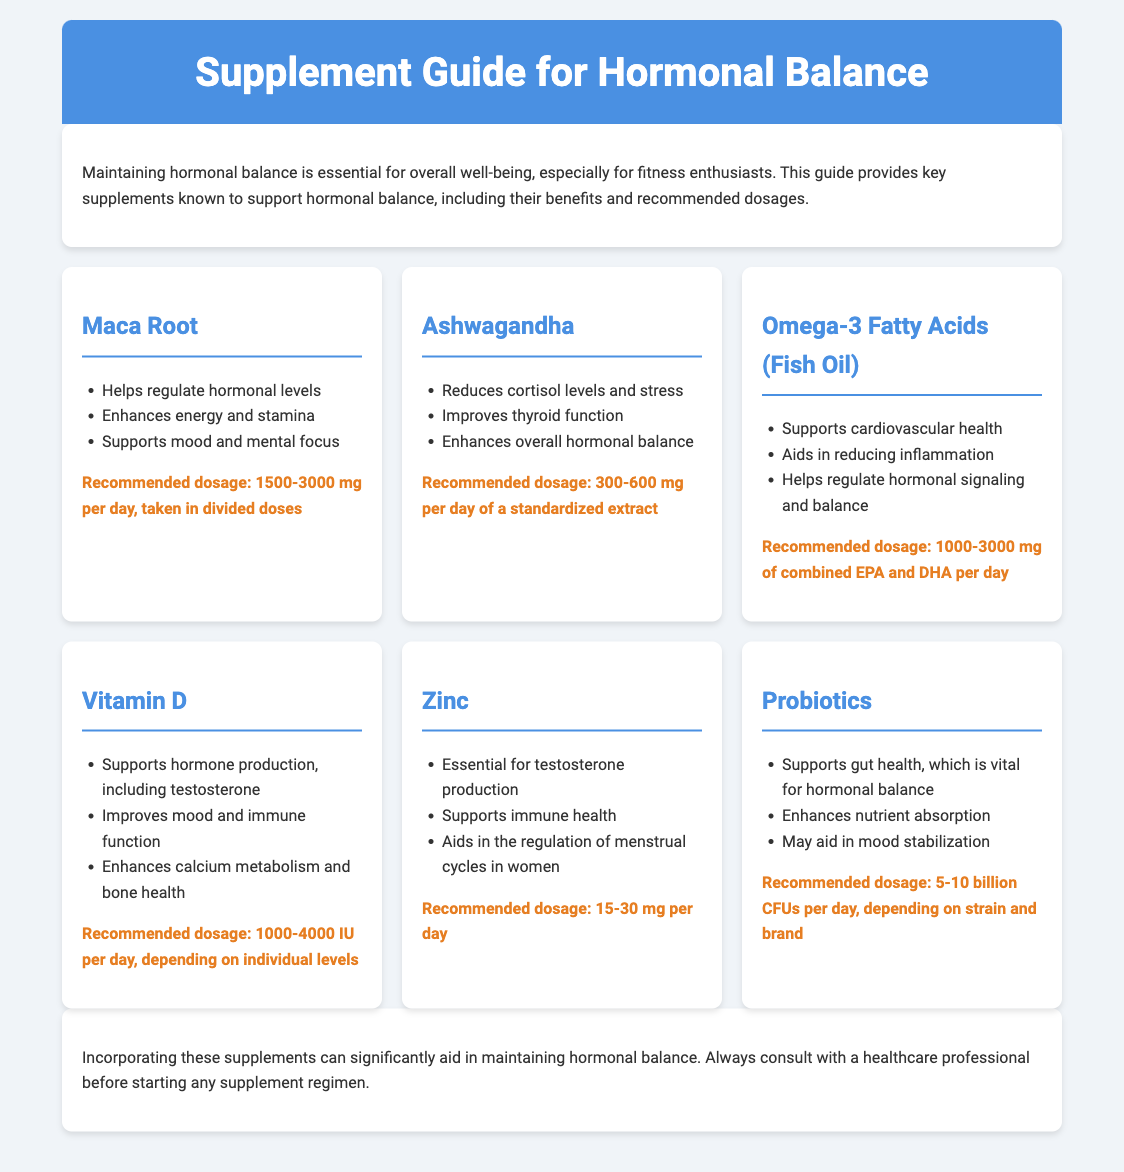What is the purpose of the guide? The guide aims to provide key supplements known to support hormonal balance and their benefits and dosages.
Answer: To support hormonal balance What is the recommended dosage of Maca Root? The recommended dosage for Maca Root is mentioned in the document as a specific range.
Answer: 1500-3000 mg per day Which supplement helps regulate cortisol levels? The document specifies that Ashwagandha is beneficial for reducing cortisol levels and stress.
Answer: Ashwagandha How many billion CFUs of Probiotics are recommended? The document provides specific information about the recommended dosage for Probiotics in terms of CFUs.
Answer: 5-10 billion CFUs per day What is a benefit of Omega-3 Fatty Acids? The document lists several benefits for Omega-3 Fatty Acids, one of them being their role in hormonal regulation.
Answer: Helps regulate hormonal signaling What vitamin is essential for testosterone production? The document identifies Vitamin D as playing an important role in hormone production, including testosterone.
Answer: Vitamin D What is the main focus of the conclusion? The conclusion summarizes the guide's content about supplements aiding in hormonal balance and advises consultation with professionals.
Answer: Aiding in maintaining hormonal balance Which supplement is essential for immune health? The document indicates that Zinc supports immune health among its benefits.
Answer: Zinc 